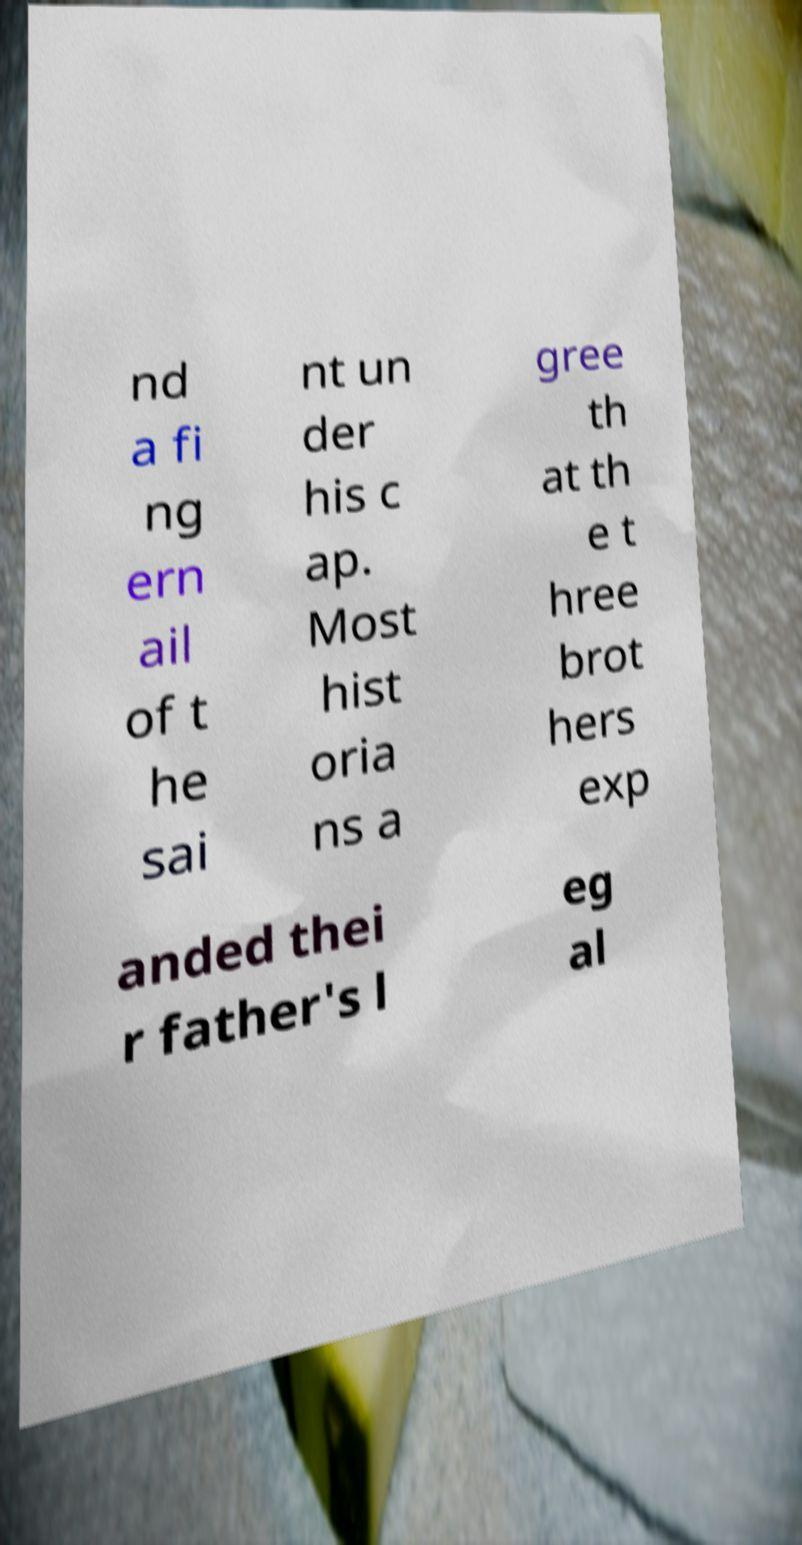Please identify and transcribe the text found in this image. nd a fi ng ern ail of t he sai nt un der his c ap. Most hist oria ns a gree th at th e t hree brot hers exp anded thei r father's l eg al 